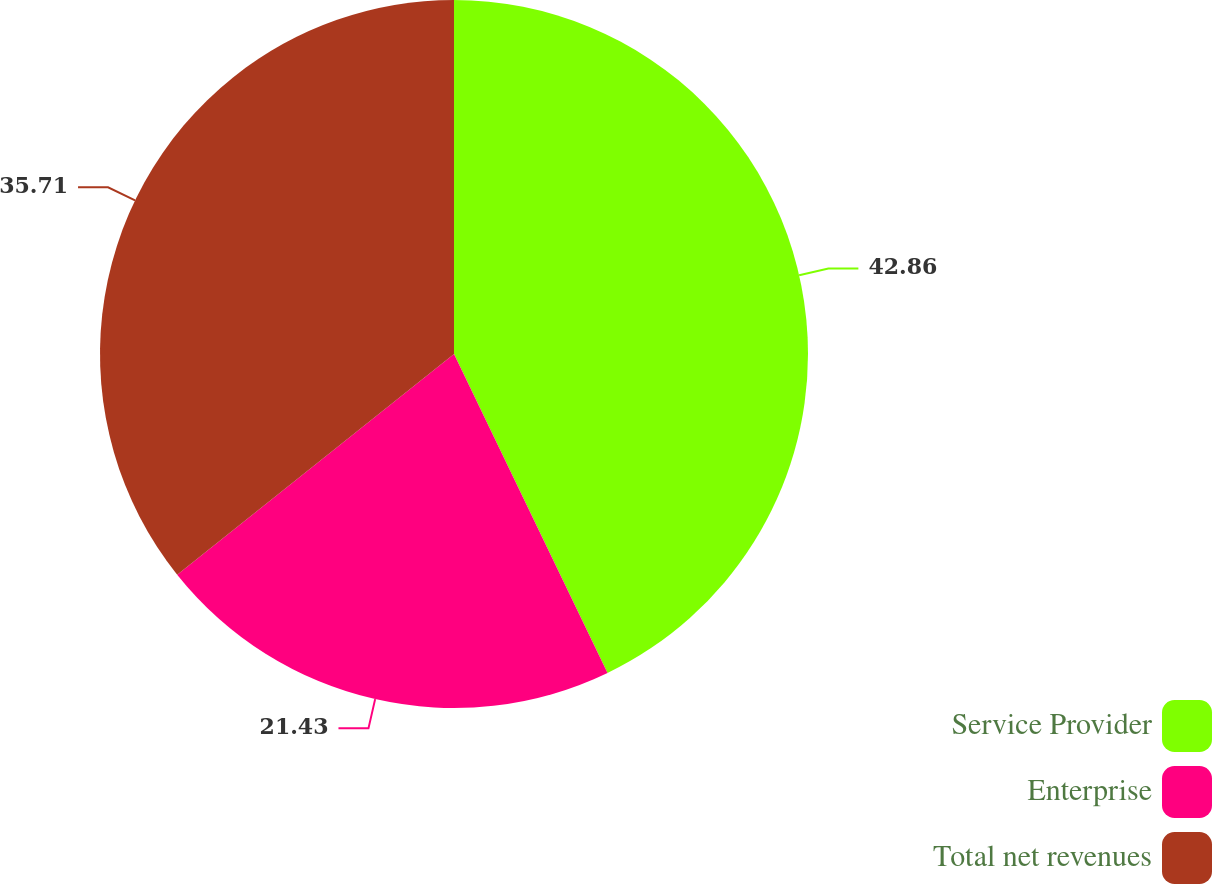<chart> <loc_0><loc_0><loc_500><loc_500><pie_chart><fcel>Service Provider<fcel>Enterprise<fcel>Total net revenues<nl><fcel>42.86%<fcel>21.43%<fcel>35.71%<nl></chart> 